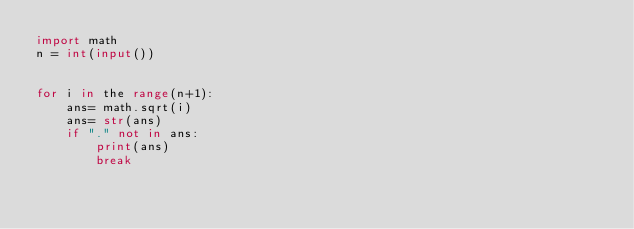Convert code to text. <code><loc_0><loc_0><loc_500><loc_500><_Python_>import math
n = int(input())


for i in the range(n+1):
    ans= math.sqrt(i)
    ans= str(ans)
    if "." not in ans:
        print(ans)
        break
</code> 